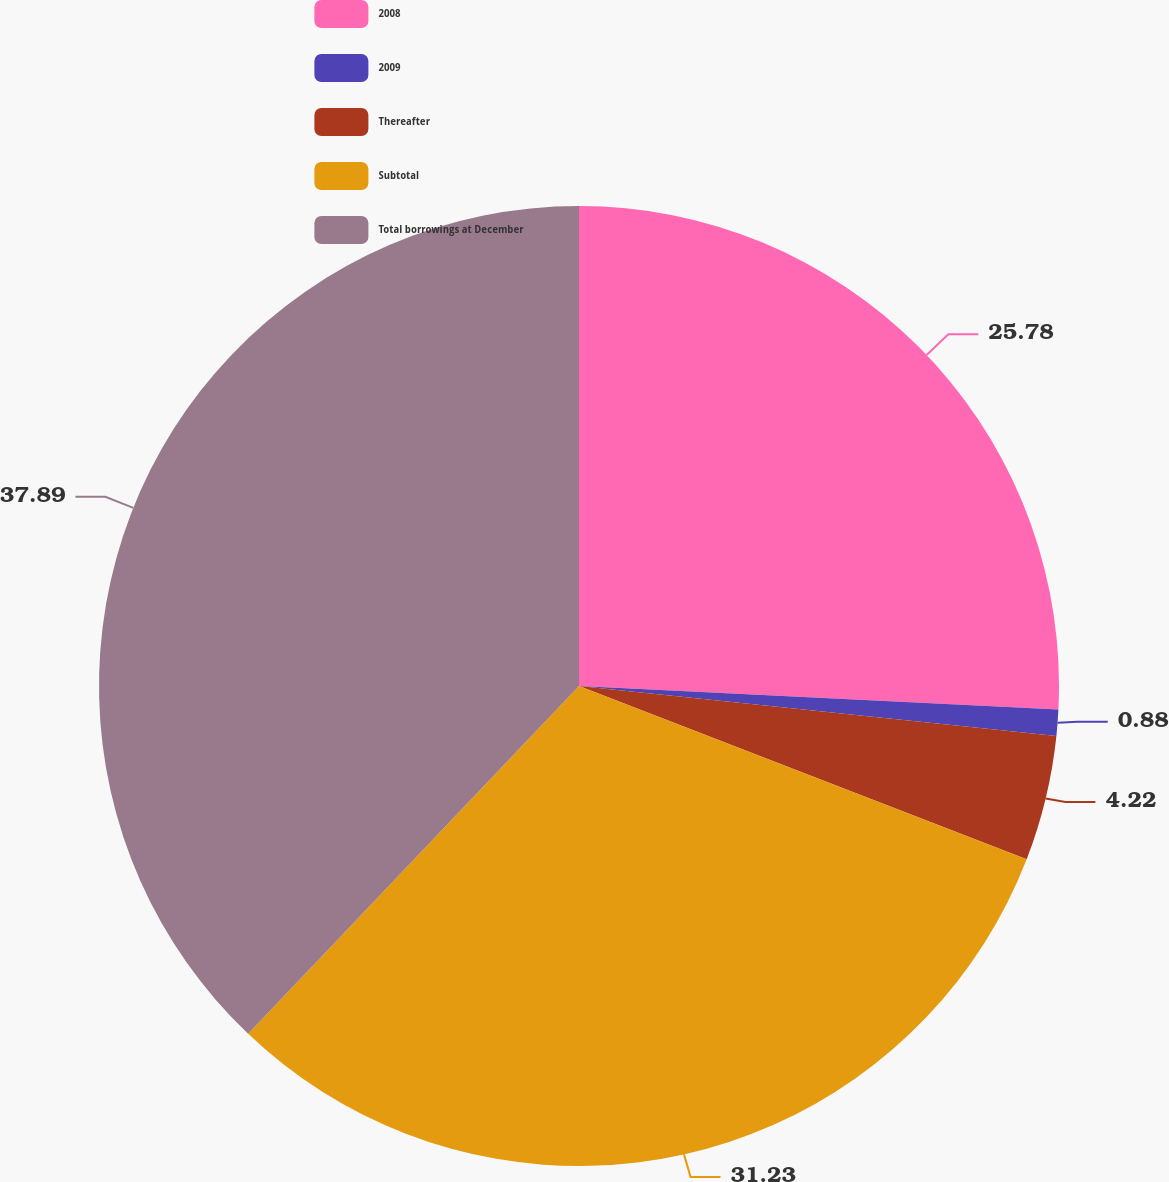Convert chart. <chart><loc_0><loc_0><loc_500><loc_500><pie_chart><fcel>2008<fcel>2009<fcel>Thereafter<fcel>Subtotal<fcel>Total borrowings at December<nl><fcel>25.78%<fcel>0.88%<fcel>4.22%<fcel>31.23%<fcel>37.9%<nl></chart> 